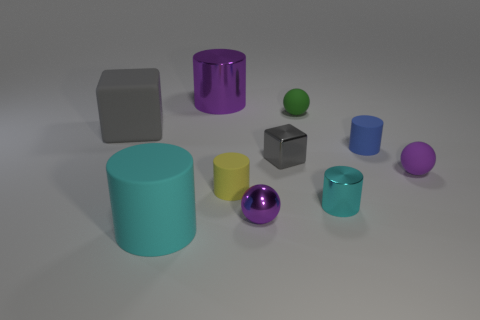Subtract all big cylinders. How many cylinders are left? 3 Subtract all cyan spheres. How many cyan cylinders are left? 2 Subtract all blue cylinders. How many cylinders are left? 4 Subtract 1 cylinders. How many cylinders are left? 4 Subtract all blocks. How many objects are left? 8 Subtract all green cylinders. Subtract all gray blocks. How many cylinders are left? 5 Subtract all blue metal blocks. Subtract all large gray matte blocks. How many objects are left? 9 Add 8 cyan shiny cylinders. How many cyan shiny cylinders are left? 9 Add 5 tiny yellow cylinders. How many tiny yellow cylinders exist? 6 Subtract 0 brown cylinders. How many objects are left? 10 